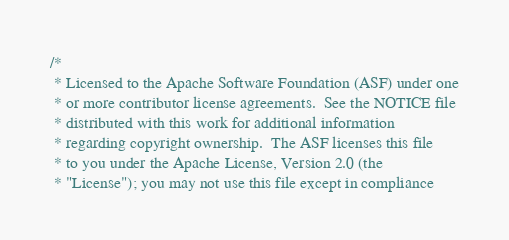Convert code to text. <code><loc_0><loc_0><loc_500><loc_500><_Scala_>/*
 * Licensed to the Apache Software Foundation (ASF) under one
 * or more contributor license agreements.  See the NOTICE file
 * distributed with this work for additional information
 * regarding copyright ownership.  The ASF licenses this file
 * to you under the Apache License, Version 2.0 (the
 * "License"); you may not use this file except in compliance</code> 